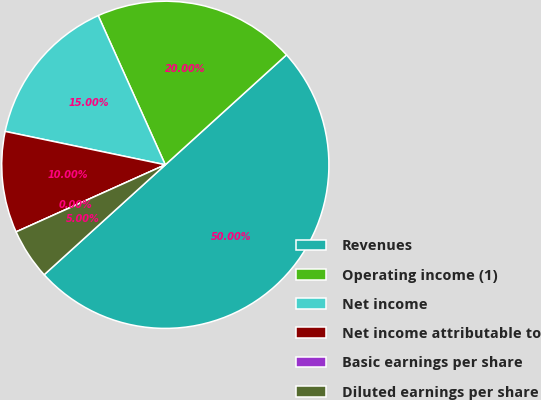Convert chart to OTSL. <chart><loc_0><loc_0><loc_500><loc_500><pie_chart><fcel>Revenues<fcel>Operating income (1)<fcel>Net income<fcel>Net income attributable to<fcel>Basic earnings per share<fcel>Diluted earnings per share<nl><fcel>50.0%<fcel>20.0%<fcel>15.0%<fcel>10.0%<fcel>0.0%<fcel>5.0%<nl></chart> 